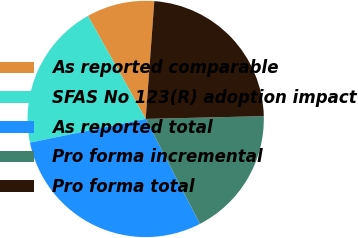<chart> <loc_0><loc_0><loc_500><loc_500><pie_chart><fcel>As reported comparable<fcel>SFAS No 123(R) adoption impact<fcel>As reported total<fcel>Pro forma incremental<fcel>Pro forma total<nl><fcel>9.3%<fcel>20.08%<fcel>29.38%<fcel>17.78%<fcel>23.46%<nl></chart> 